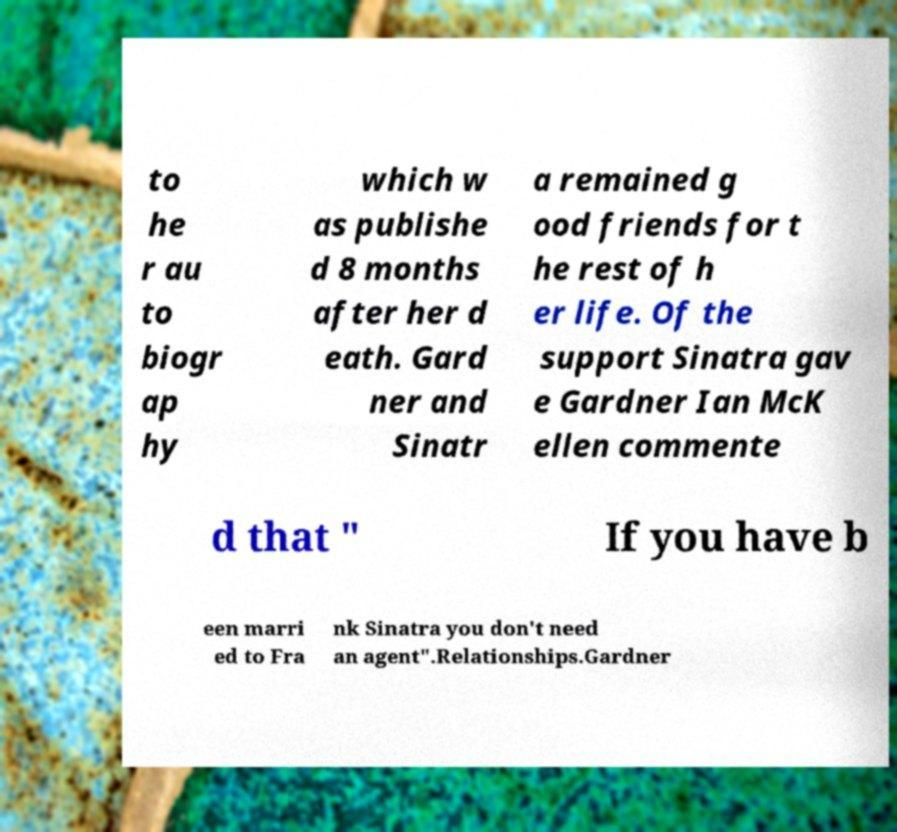Can you read and provide the text displayed in the image?This photo seems to have some interesting text. Can you extract and type it out for me? to he r au to biogr ap hy which w as publishe d 8 months after her d eath. Gard ner and Sinatr a remained g ood friends for t he rest of h er life. Of the support Sinatra gav e Gardner Ian McK ellen commente d that " If you have b een marri ed to Fra nk Sinatra you don't need an agent".Relationships.Gardner 